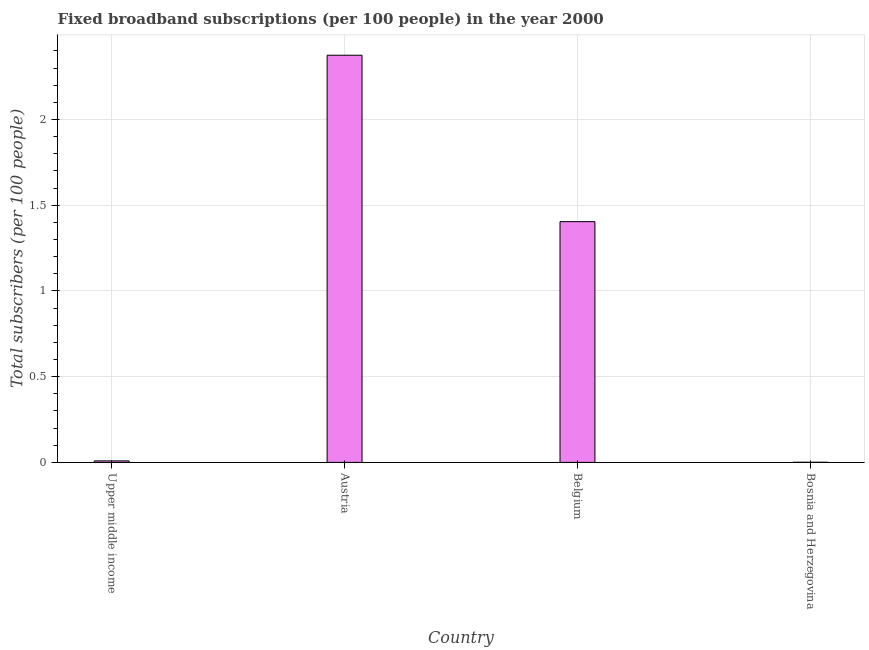Does the graph contain grids?
Offer a very short reply. Yes. What is the title of the graph?
Ensure brevity in your answer.  Fixed broadband subscriptions (per 100 people) in the year 2000. What is the label or title of the Y-axis?
Your response must be concise. Total subscribers (per 100 people). What is the total number of fixed broadband subscriptions in Upper middle income?
Provide a succinct answer. 0.01. Across all countries, what is the maximum total number of fixed broadband subscriptions?
Give a very brief answer. 2.38. Across all countries, what is the minimum total number of fixed broadband subscriptions?
Offer a terse response. 0. In which country was the total number of fixed broadband subscriptions maximum?
Ensure brevity in your answer.  Austria. In which country was the total number of fixed broadband subscriptions minimum?
Keep it short and to the point. Bosnia and Herzegovina. What is the sum of the total number of fixed broadband subscriptions?
Provide a succinct answer. 3.79. What is the difference between the total number of fixed broadband subscriptions in Belgium and Bosnia and Herzegovina?
Ensure brevity in your answer.  1.4. What is the average total number of fixed broadband subscriptions per country?
Give a very brief answer. 0.95. What is the median total number of fixed broadband subscriptions?
Offer a very short reply. 0.71. In how many countries, is the total number of fixed broadband subscriptions greater than 0.4 ?
Offer a very short reply. 2. What is the ratio of the total number of fixed broadband subscriptions in Austria to that in Belgium?
Provide a short and direct response. 1.69. Is the difference between the total number of fixed broadband subscriptions in Austria and Upper middle income greater than the difference between any two countries?
Your response must be concise. No. What is the difference between the highest and the second highest total number of fixed broadband subscriptions?
Provide a succinct answer. 0.97. Is the sum of the total number of fixed broadband subscriptions in Austria and Belgium greater than the maximum total number of fixed broadband subscriptions across all countries?
Ensure brevity in your answer.  Yes. What is the difference between the highest and the lowest total number of fixed broadband subscriptions?
Keep it short and to the point. 2.37. Are the values on the major ticks of Y-axis written in scientific E-notation?
Provide a short and direct response. No. What is the Total subscribers (per 100 people) of Upper middle income?
Your answer should be very brief. 0.01. What is the Total subscribers (per 100 people) of Austria?
Ensure brevity in your answer.  2.38. What is the Total subscribers (per 100 people) in Belgium?
Offer a terse response. 1.4. What is the Total subscribers (per 100 people) in Bosnia and Herzegovina?
Your answer should be compact. 0. What is the difference between the Total subscribers (per 100 people) in Upper middle income and Austria?
Keep it short and to the point. -2.37. What is the difference between the Total subscribers (per 100 people) in Upper middle income and Belgium?
Give a very brief answer. -1.4. What is the difference between the Total subscribers (per 100 people) in Upper middle income and Bosnia and Herzegovina?
Your answer should be very brief. 0.01. What is the difference between the Total subscribers (per 100 people) in Austria and Belgium?
Your response must be concise. 0.97. What is the difference between the Total subscribers (per 100 people) in Austria and Bosnia and Herzegovina?
Your response must be concise. 2.37. What is the difference between the Total subscribers (per 100 people) in Belgium and Bosnia and Herzegovina?
Provide a succinct answer. 1.4. What is the ratio of the Total subscribers (per 100 people) in Upper middle income to that in Austria?
Your answer should be compact. 0. What is the ratio of the Total subscribers (per 100 people) in Upper middle income to that in Belgium?
Provide a succinct answer. 0.01. What is the ratio of the Total subscribers (per 100 people) in Upper middle income to that in Bosnia and Herzegovina?
Offer a terse response. 12.37. What is the ratio of the Total subscribers (per 100 people) in Austria to that in Belgium?
Offer a terse response. 1.69. What is the ratio of the Total subscribers (per 100 people) in Austria to that in Bosnia and Herzegovina?
Provide a short and direct response. 3373.15. What is the ratio of the Total subscribers (per 100 people) in Belgium to that in Bosnia and Herzegovina?
Keep it short and to the point. 1994.52. 